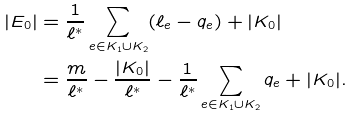<formula> <loc_0><loc_0><loc_500><loc_500>| E _ { 0 } | & = \frac { 1 } { \ell ^ { * } } \sum _ { e \in K _ { 1 } \cup K _ { 2 } } ( \ell _ { e } - q _ { e } ) + | K _ { 0 } | \\ & = \frac { m } { \ell ^ { * } } - \frac { | K _ { 0 } | } { \ell ^ { * } } - \frac { 1 } { \ell ^ { * } } \sum _ { e \in K _ { 1 } \cup K _ { 2 } } q _ { e } + | K _ { 0 } | .</formula> 